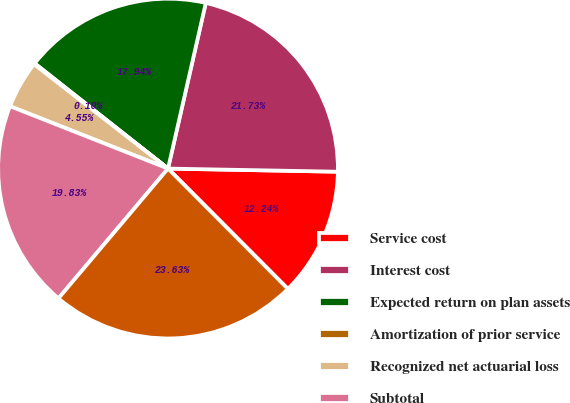Convert chart. <chart><loc_0><loc_0><loc_500><loc_500><pie_chart><fcel>Service cost<fcel>Interest cost<fcel>Expected return on plan assets<fcel>Amortization of prior service<fcel>Recognized net actuarial loss<fcel>Subtotal<fcel>Net periodic benefit cost<nl><fcel>12.24%<fcel>21.73%<fcel>17.94%<fcel>0.1%<fcel>4.55%<fcel>19.83%<fcel>23.63%<nl></chart> 